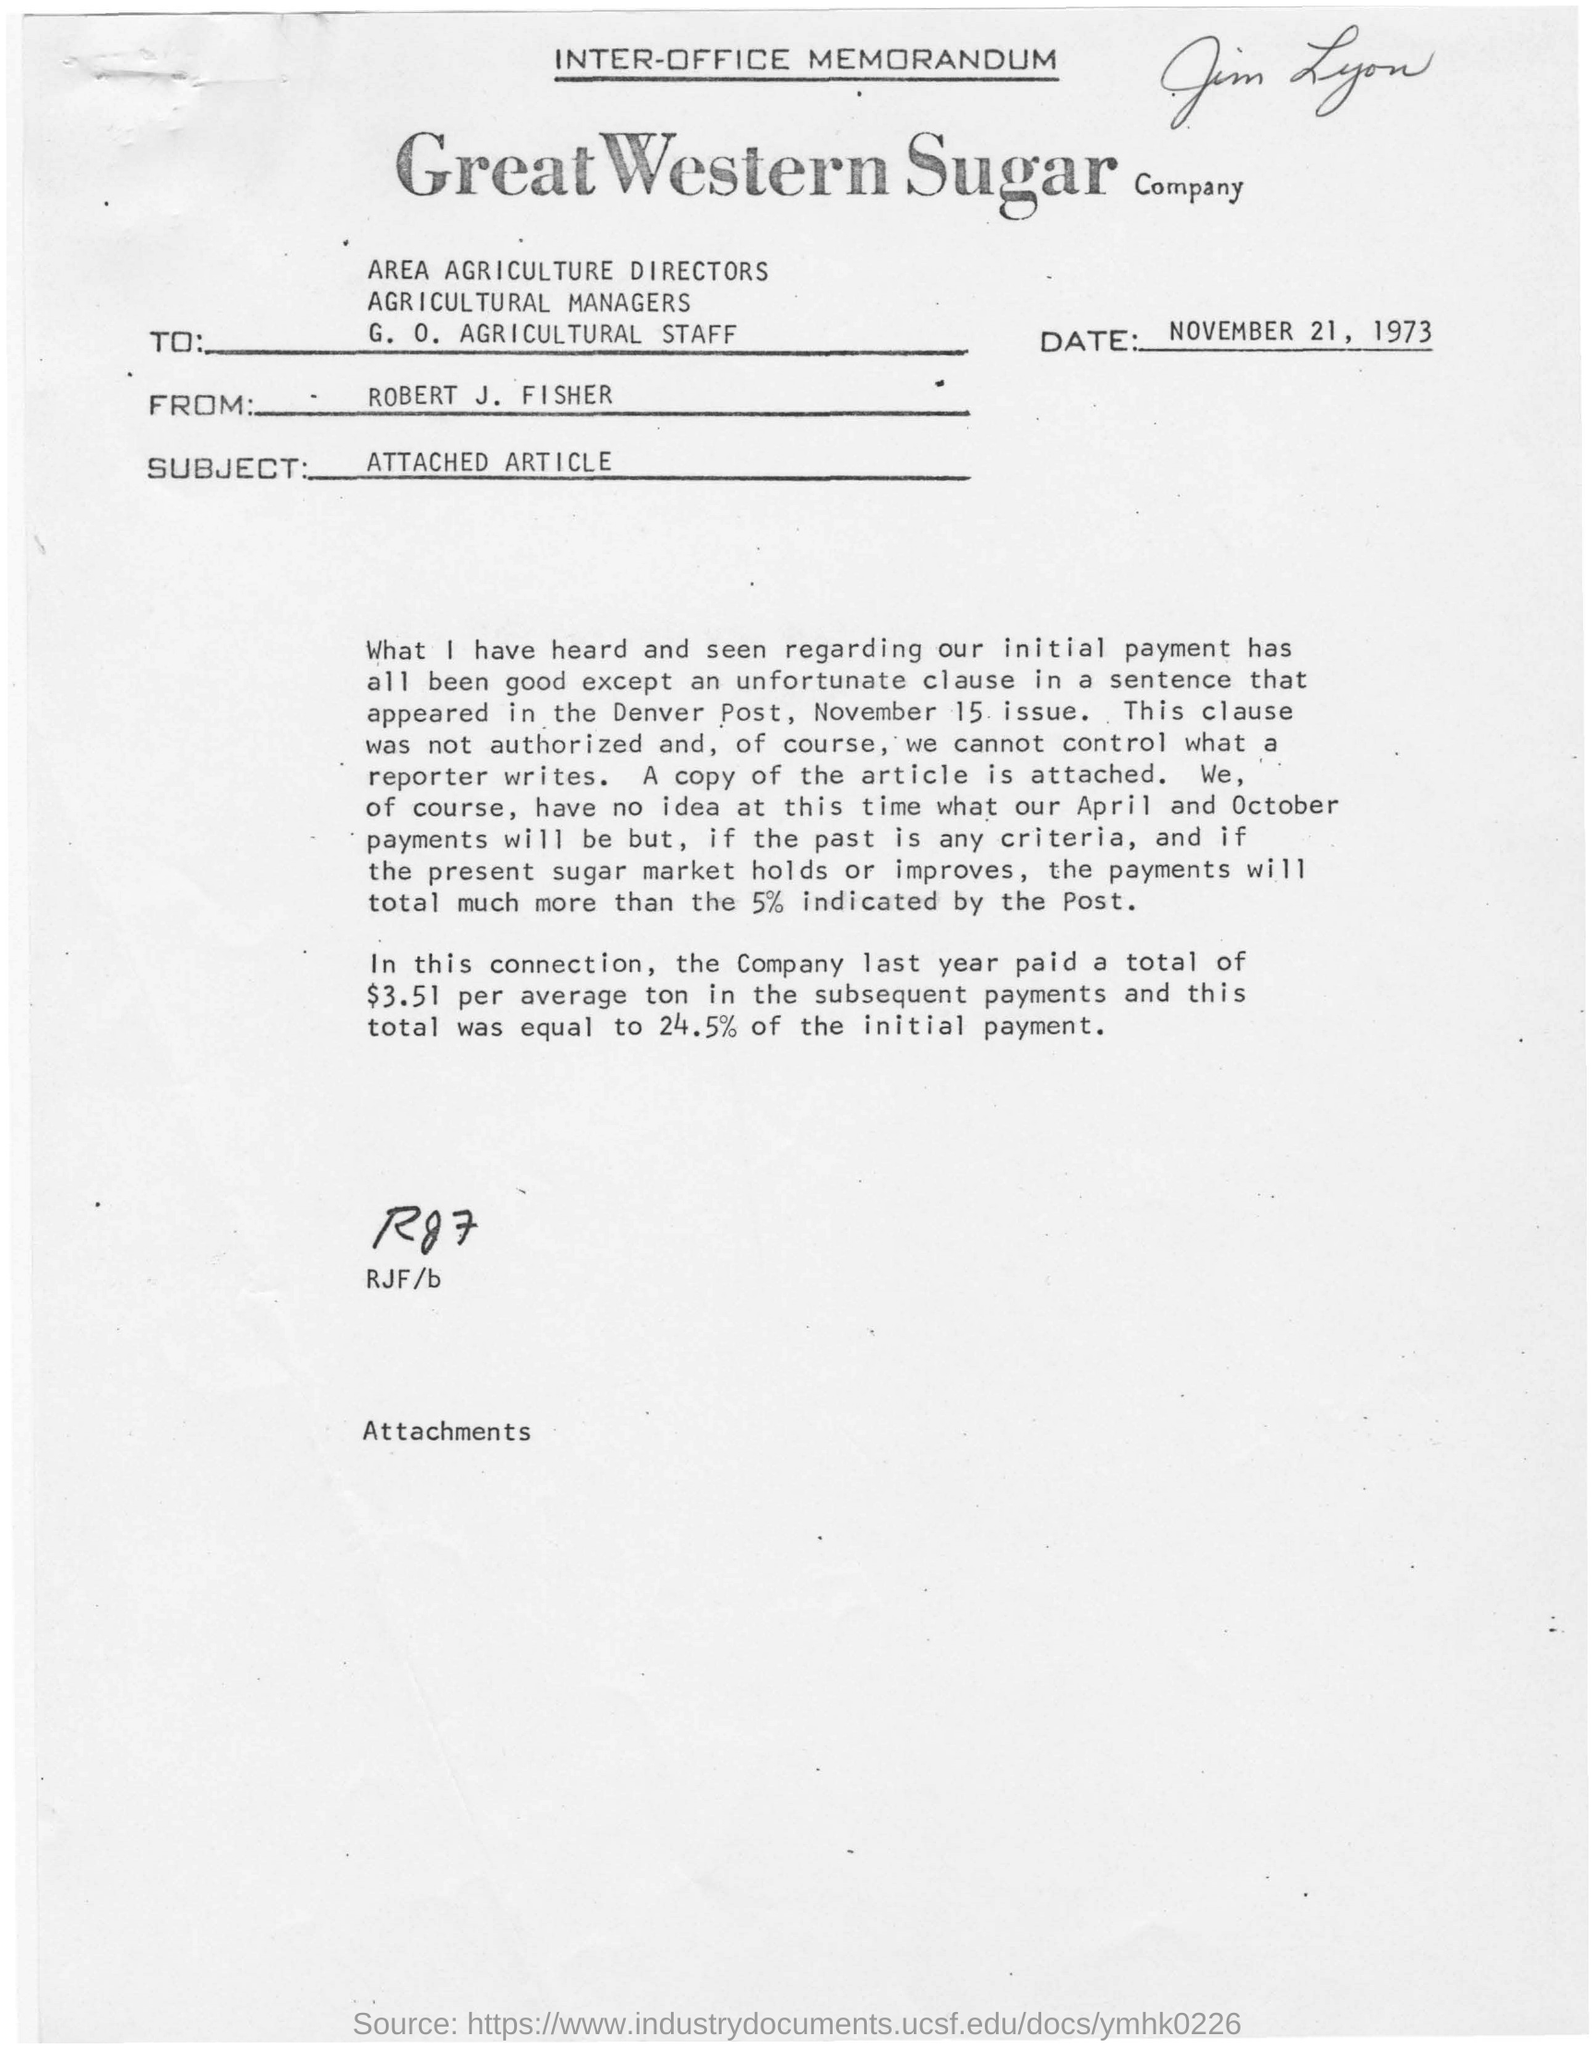Identify some key points in this picture. The Great Western Sugar Company paid a total of $3.51 per average ton in subsequent payments last year. The memorandum is dated November 21, 1973. The article attached to this inter-office memorandum is the subject of this memorandum. What has been mentioned above regarding RJF/b? RG7... The Great Western Sugar Company is the name of a sugar company. 